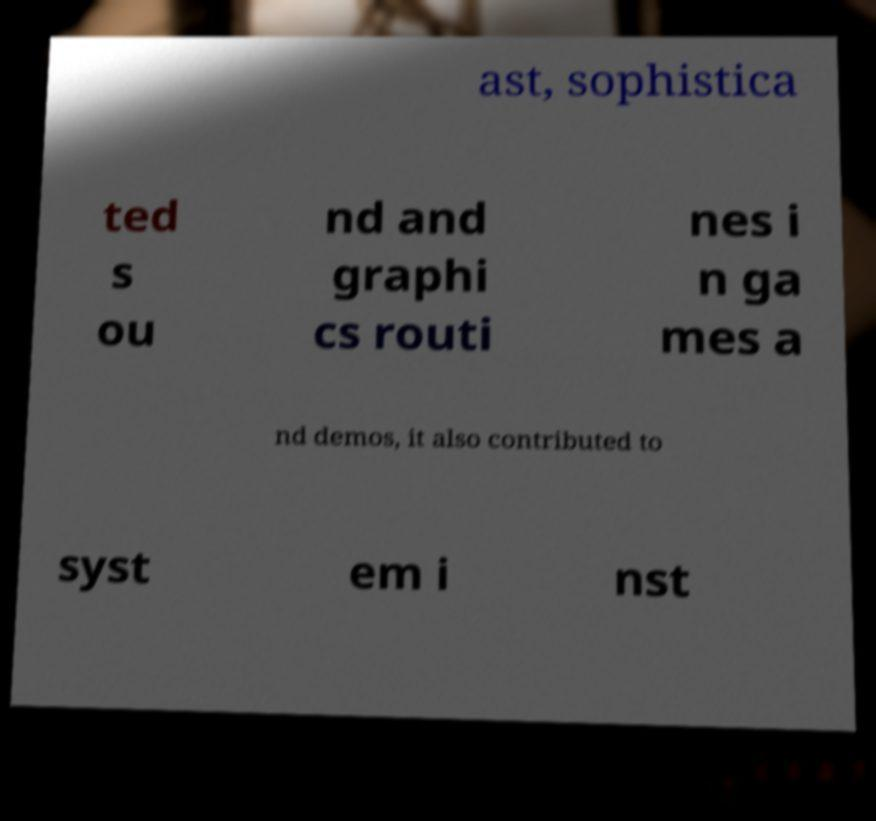There's text embedded in this image that I need extracted. Can you transcribe it verbatim? ast, sophistica ted s ou nd and graphi cs routi nes i n ga mes a nd demos, it also contributed to syst em i nst 